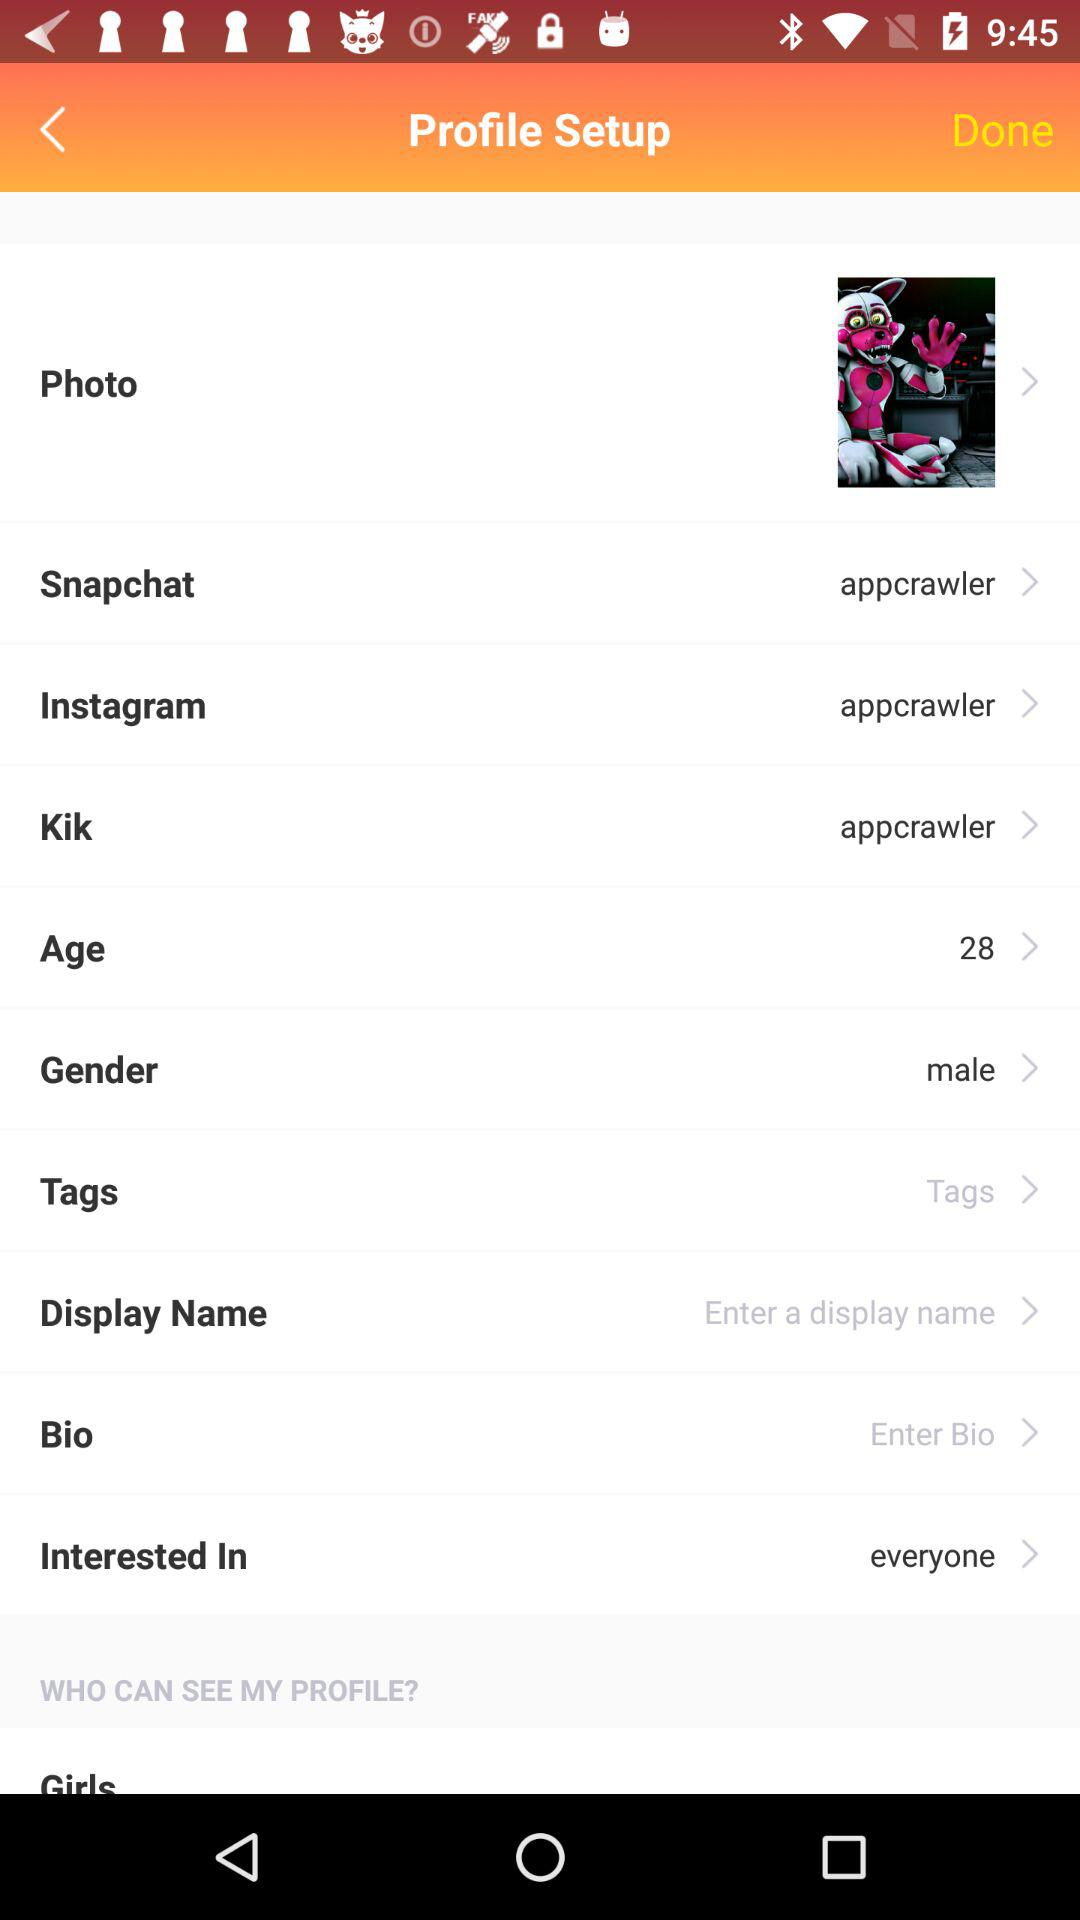What is the gender? The gender is male. 